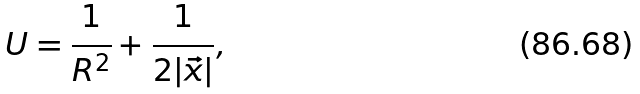<formula> <loc_0><loc_0><loc_500><loc_500>U = \frac { 1 } { R ^ { 2 } } + \frac { 1 } { 2 | \vec { x } | } ,</formula> 